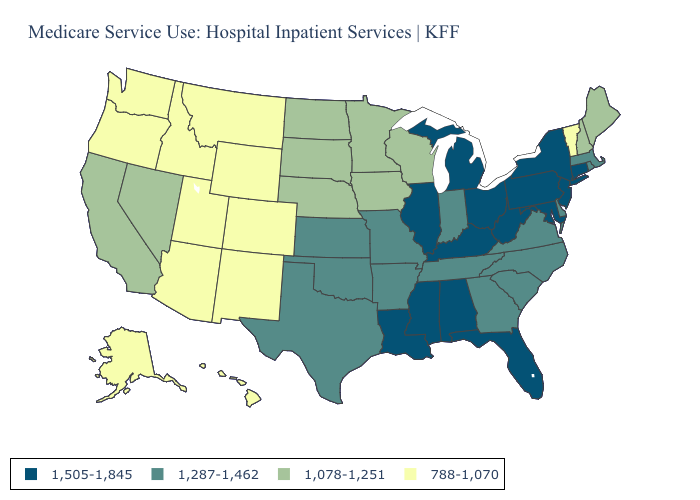What is the value of Wisconsin?
Quick response, please. 1,078-1,251. Name the states that have a value in the range 1,505-1,845?
Quick response, please. Alabama, Connecticut, Florida, Illinois, Kentucky, Louisiana, Maryland, Michigan, Mississippi, New Jersey, New York, Ohio, Pennsylvania, West Virginia. Does the map have missing data?
Write a very short answer. No. Is the legend a continuous bar?
Keep it brief. No. Name the states that have a value in the range 1,078-1,251?
Quick response, please. California, Iowa, Maine, Minnesota, Nebraska, Nevada, New Hampshire, North Dakota, South Dakota, Wisconsin. Name the states that have a value in the range 1,078-1,251?
Concise answer only. California, Iowa, Maine, Minnesota, Nebraska, Nevada, New Hampshire, North Dakota, South Dakota, Wisconsin. What is the highest value in the MidWest ?
Write a very short answer. 1,505-1,845. What is the highest value in the Northeast ?
Concise answer only. 1,505-1,845. Does Florida have a higher value than North Carolina?
Answer briefly. Yes. Which states have the highest value in the USA?
Be succinct. Alabama, Connecticut, Florida, Illinois, Kentucky, Louisiana, Maryland, Michigan, Mississippi, New Jersey, New York, Ohio, Pennsylvania, West Virginia. What is the value of Wyoming?
Answer briefly. 788-1,070. What is the highest value in the USA?
Concise answer only. 1,505-1,845. Name the states that have a value in the range 1,505-1,845?
Give a very brief answer. Alabama, Connecticut, Florida, Illinois, Kentucky, Louisiana, Maryland, Michigan, Mississippi, New Jersey, New York, Ohio, Pennsylvania, West Virginia. What is the lowest value in the USA?
Keep it brief. 788-1,070. What is the highest value in states that border Minnesota?
Short answer required. 1,078-1,251. 